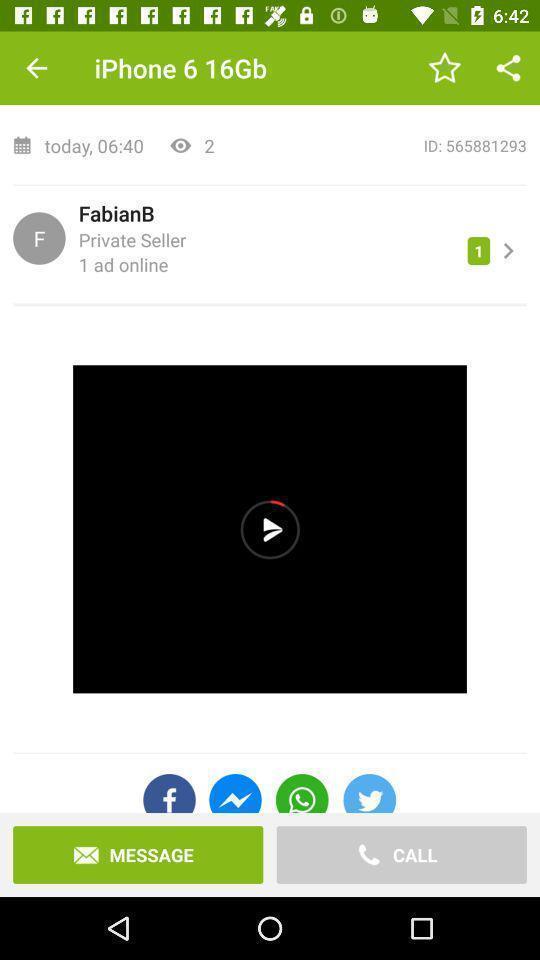Describe the content in this image. Screen page with message and call options. 